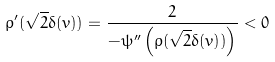Convert formula to latex. <formula><loc_0><loc_0><loc_500><loc_500>\rho ^ { \prime } ( \sqrt { 2 } \delta ( v ) ) = \frac { 2 } { - \psi ^ { \prime \prime } \left ( \rho ( \sqrt { 2 } \delta ( v ) ) \right ) } < 0</formula> 